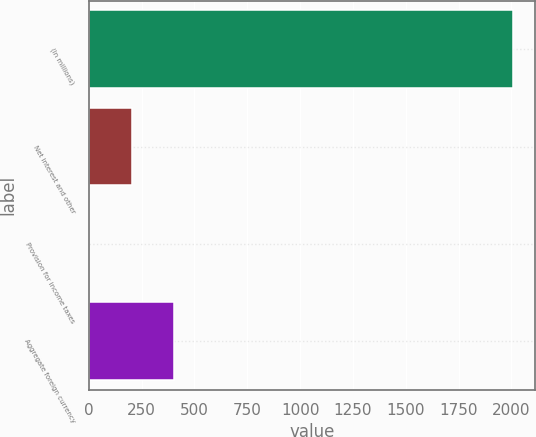<chart> <loc_0><loc_0><loc_500><loc_500><bar_chart><fcel>(In millions)<fcel>Net interest and other<fcel>Provision for income taxes<fcel>Aggregate foreign currency<nl><fcel>2010<fcel>201.9<fcel>1<fcel>402.8<nl></chart> 